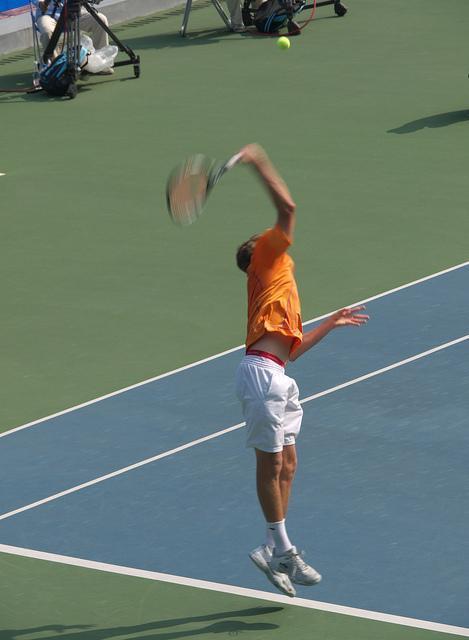How many people can be seen?
Give a very brief answer. 2. 